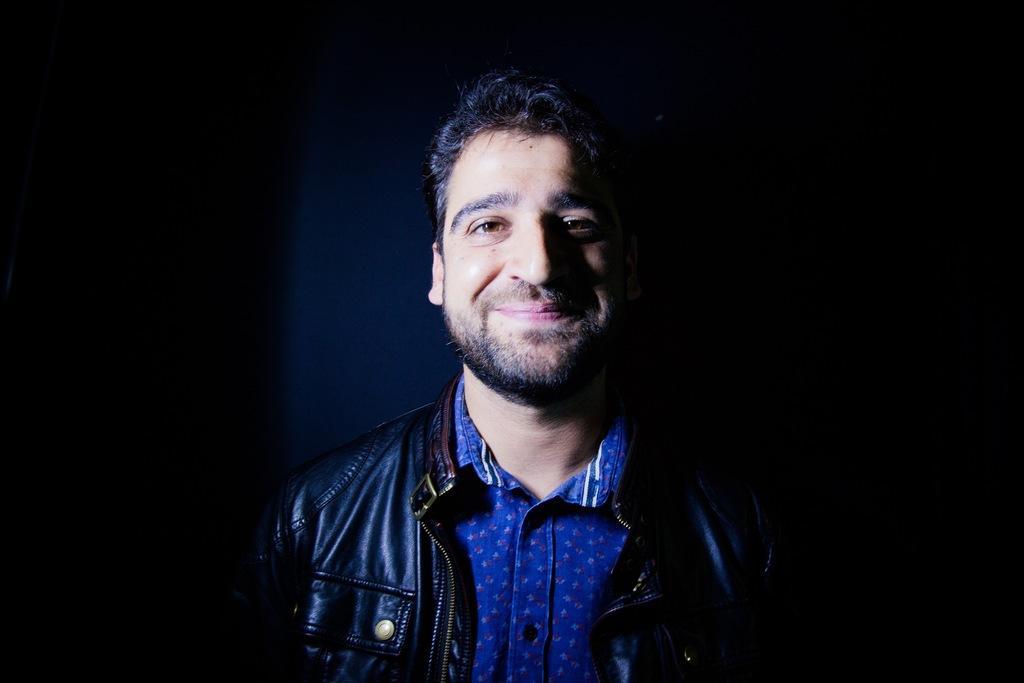In one or two sentences, can you explain what this image depicts? In the center of the image we can see a man. 